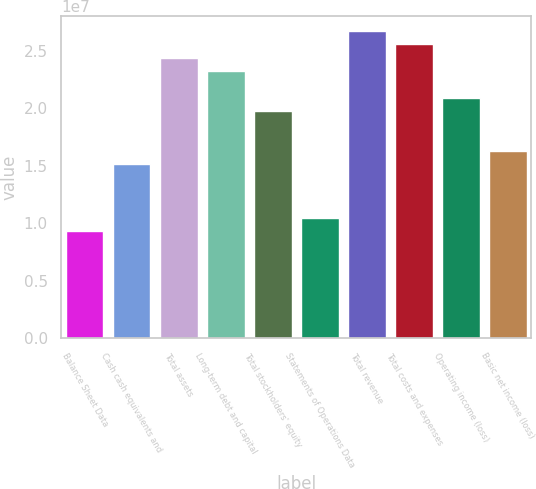Convert chart to OTSL. <chart><loc_0><loc_0><loc_500><loc_500><bar_chart><fcel>Balance Sheet Data<fcel>Cash cash equivalents and<fcel>Total assets<fcel>Long-term debt and capital<fcel>Total stockholders' equity<fcel>Statements of Operations Data<fcel>Total revenue<fcel>Total costs and expenses<fcel>Operating income (loss)<fcel>Basic net income (loss)<nl><fcel>9.29375e+06<fcel>1.51023e+07<fcel>2.43961e+07<fcel>2.32344e+07<fcel>1.97492e+07<fcel>1.04555e+07<fcel>2.67195e+07<fcel>2.55578e+07<fcel>2.09109e+07<fcel>1.62641e+07<nl></chart> 